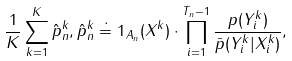Convert formula to latex. <formula><loc_0><loc_0><loc_500><loc_500>\frac { 1 } { K } \sum _ { k = 1 } ^ { K } \hat { p } _ { n } ^ { k } , \hat { p } _ { n } ^ { k } \doteq 1 _ { A _ { n } } ( X ^ { k } ) \cdot \prod _ { i = 1 } ^ { T _ { n } - 1 } \frac { p ( Y ^ { k } _ { i } ) } { \bar { p } ( Y ^ { k } _ { i } | X ^ { k } _ { i } ) } ,</formula> 